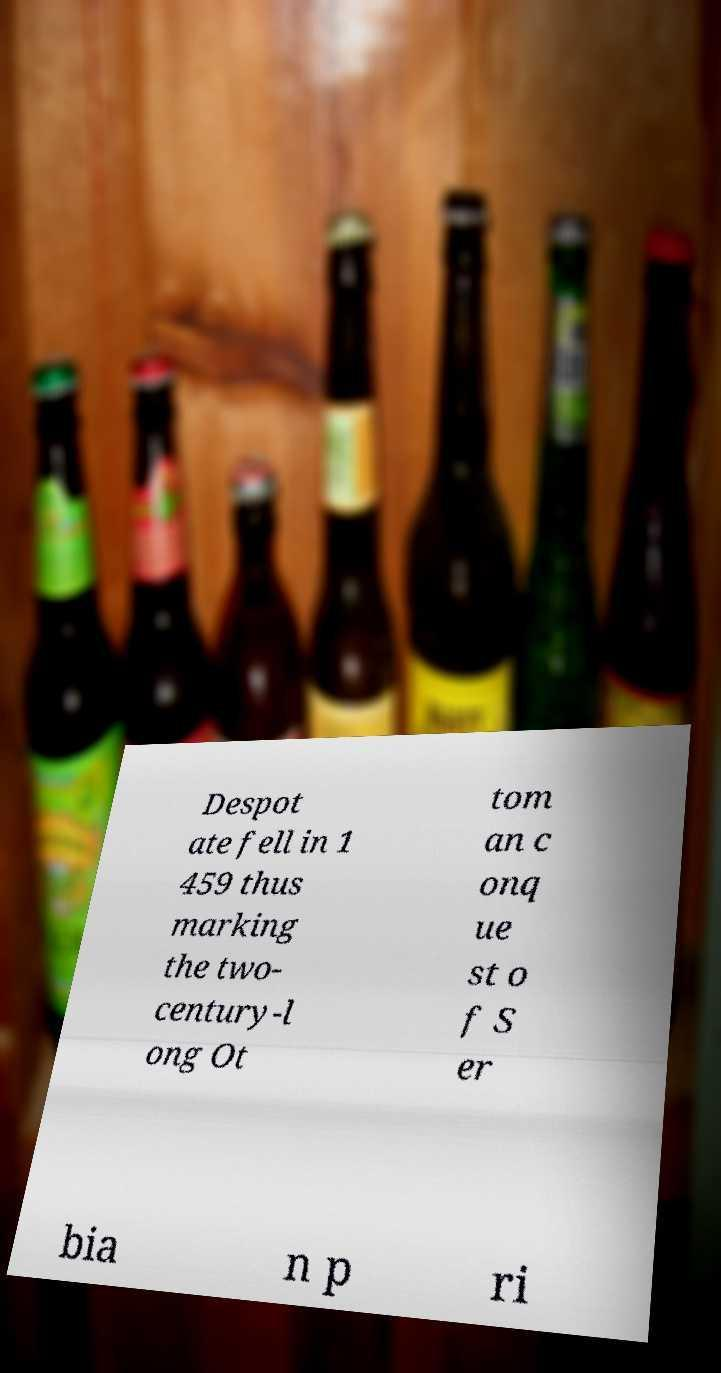For documentation purposes, I need the text within this image transcribed. Could you provide that? Despot ate fell in 1 459 thus marking the two- century-l ong Ot tom an c onq ue st o f S er bia n p ri 